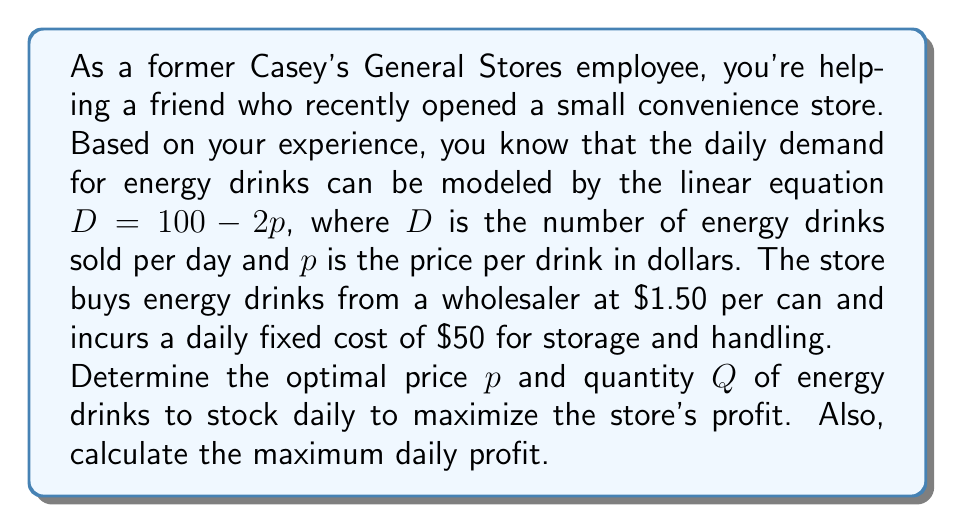Solve this math problem. Let's approach this step-by-step:

1) First, we need to set up the profit function. Profit is revenue minus costs.

2) Revenue is price times quantity: $pQ$

3) Costs include the fixed cost ($50) and the variable cost ($1.50 per can): $50 + 1.50Q$

4) So the profit function is: $\Pi = pQ - (50 + 1.50Q)$

5) We know that $Q = D = 100 - 2p$, so we can substitute this into our profit function:

   $\Pi = p(100 - 2p) - (50 + 1.50(100 - 2p))$

6) Expanding this:

   $\Pi = 100p - 2p^2 - 50 - 150 + 3p$
   $\Pi = -2p^2 + 103p - 200$

7) To find the maximum profit, we differentiate $\Pi$ with respect to $p$ and set it to zero:

   $\frac{d\Pi}{dp} = -4p + 103 = 0$

8) Solving this:

   $-4p = -103$
   $p = 25.75$

9) To confirm this is a maximum, we can check the second derivative is negative:

   $\frac{d^2\Pi}{dp^2} = -4$, which is indeed negative.

10) Now we can find $Q$:

    $Q = 100 - 2(25.75) = 48.5$

11) To find the maximum profit, we substitute these values back into our profit function:

    $\Pi = -2(25.75)^2 + 103(25.75) - 200 = 1126.5625$
Answer: The optimal price is $p = $25.75 per energy drink.
The optimal quantity to stock daily is $Q = 48.5$ energy drinks (rounded to 49 in practice).
The maximum daily profit is $\Pi = $1126.56. 